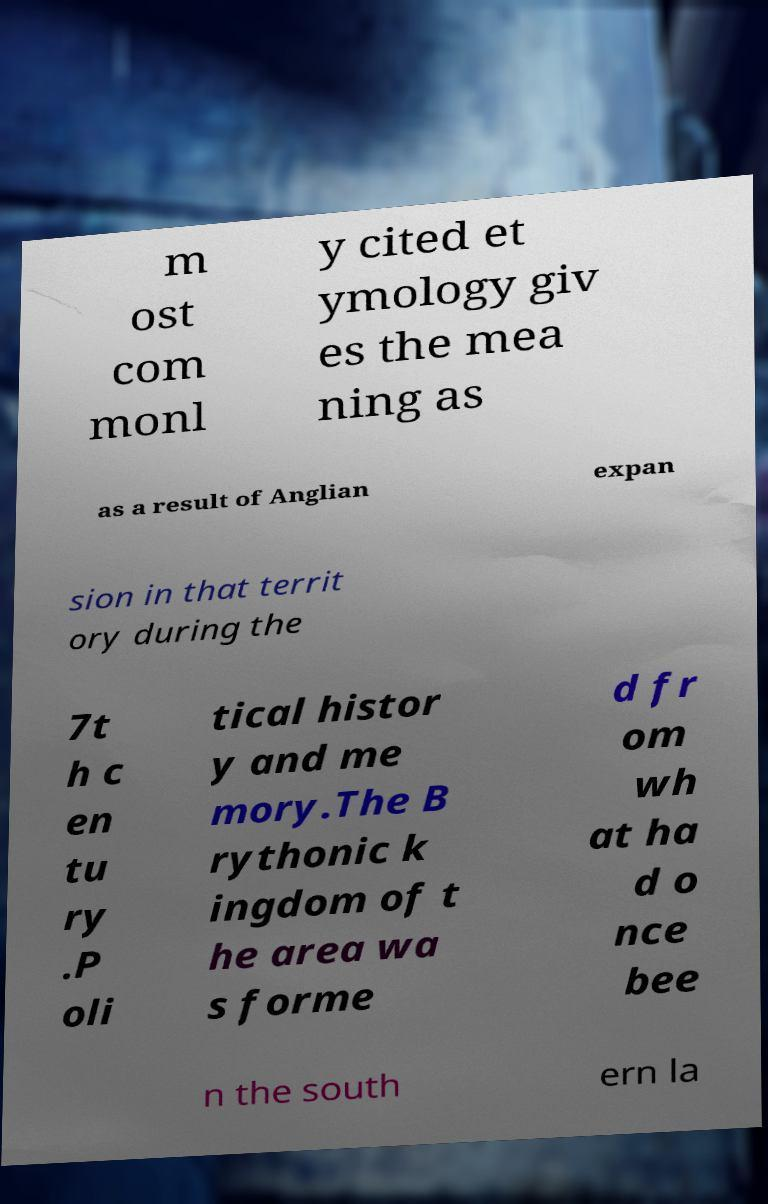Can you accurately transcribe the text from the provided image for me? m ost com monl y cited et ymology giv es the mea ning as as a result of Anglian expan sion in that territ ory during the 7t h c en tu ry .P oli tical histor y and me mory.The B rythonic k ingdom of t he area wa s forme d fr om wh at ha d o nce bee n the south ern la 